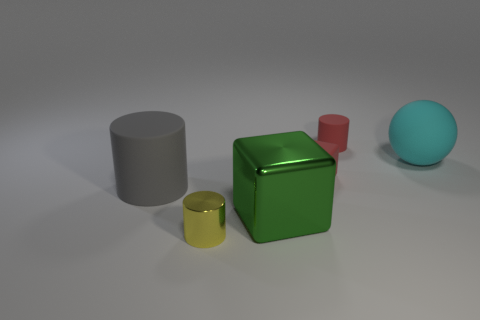Subtract all matte cylinders. How many cylinders are left? 1 Add 3 small shiny cylinders. How many objects exist? 9 Subtract all cubes. How many objects are left? 4 Subtract all red things. Subtract all large yellow cylinders. How many objects are left? 4 Add 2 big green things. How many big green things are left? 3 Add 6 yellow metallic cylinders. How many yellow metallic cylinders exist? 7 Subtract 0 blue balls. How many objects are left? 6 